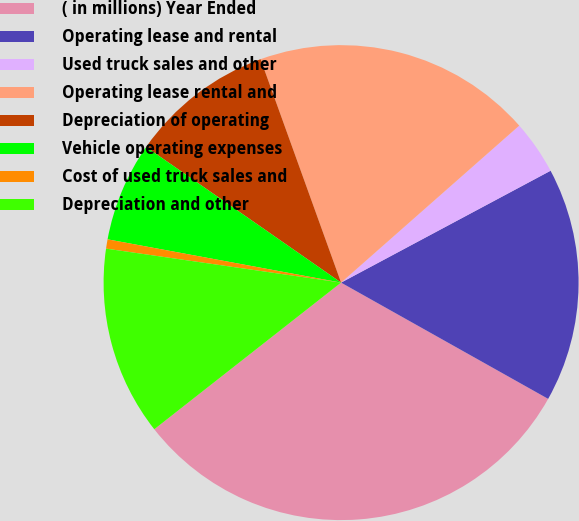Convert chart. <chart><loc_0><loc_0><loc_500><loc_500><pie_chart><fcel>( in millions) Year Ended<fcel>Operating lease and rental<fcel>Used truck sales and other<fcel>Operating lease rental and<fcel>Depreciation of operating<fcel>Vehicle operating expenses<fcel>Cost of used truck sales and<fcel>Depreciation and other<nl><fcel>31.27%<fcel>15.95%<fcel>3.69%<fcel>19.01%<fcel>9.82%<fcel>6.76%<fcel>0.63%<fcel>12.88%<nl></chart> 